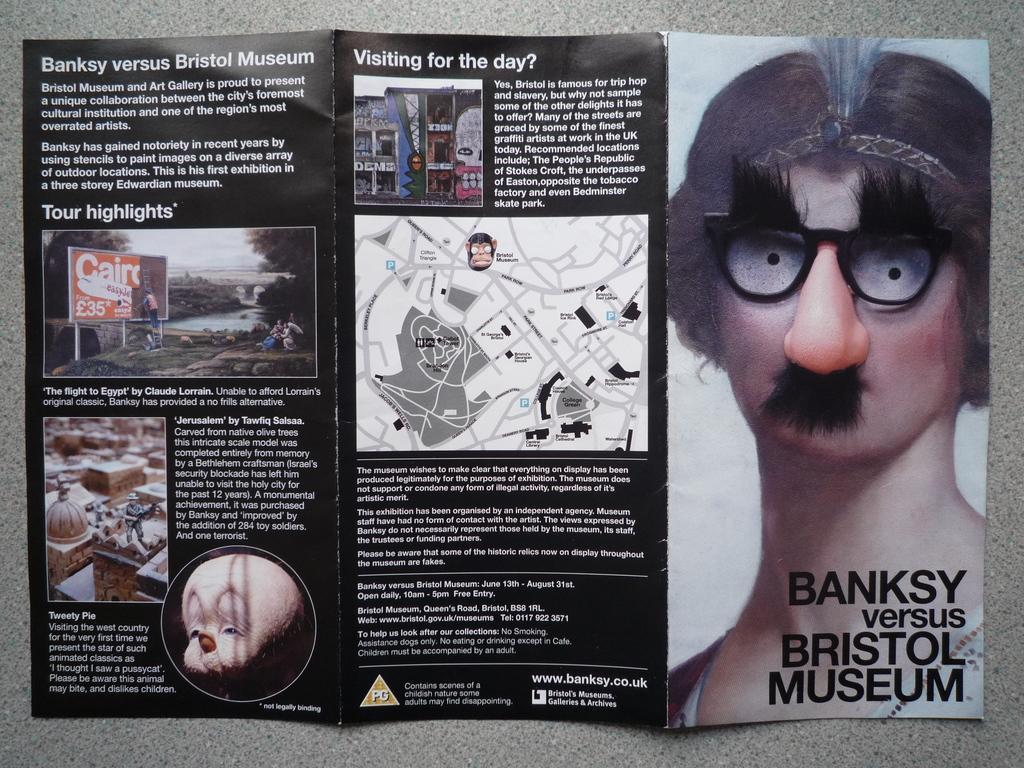Describe this image in one or two sentences. In this image I can see a pamphlet may be on the floor. This image is taken may be in a room. 